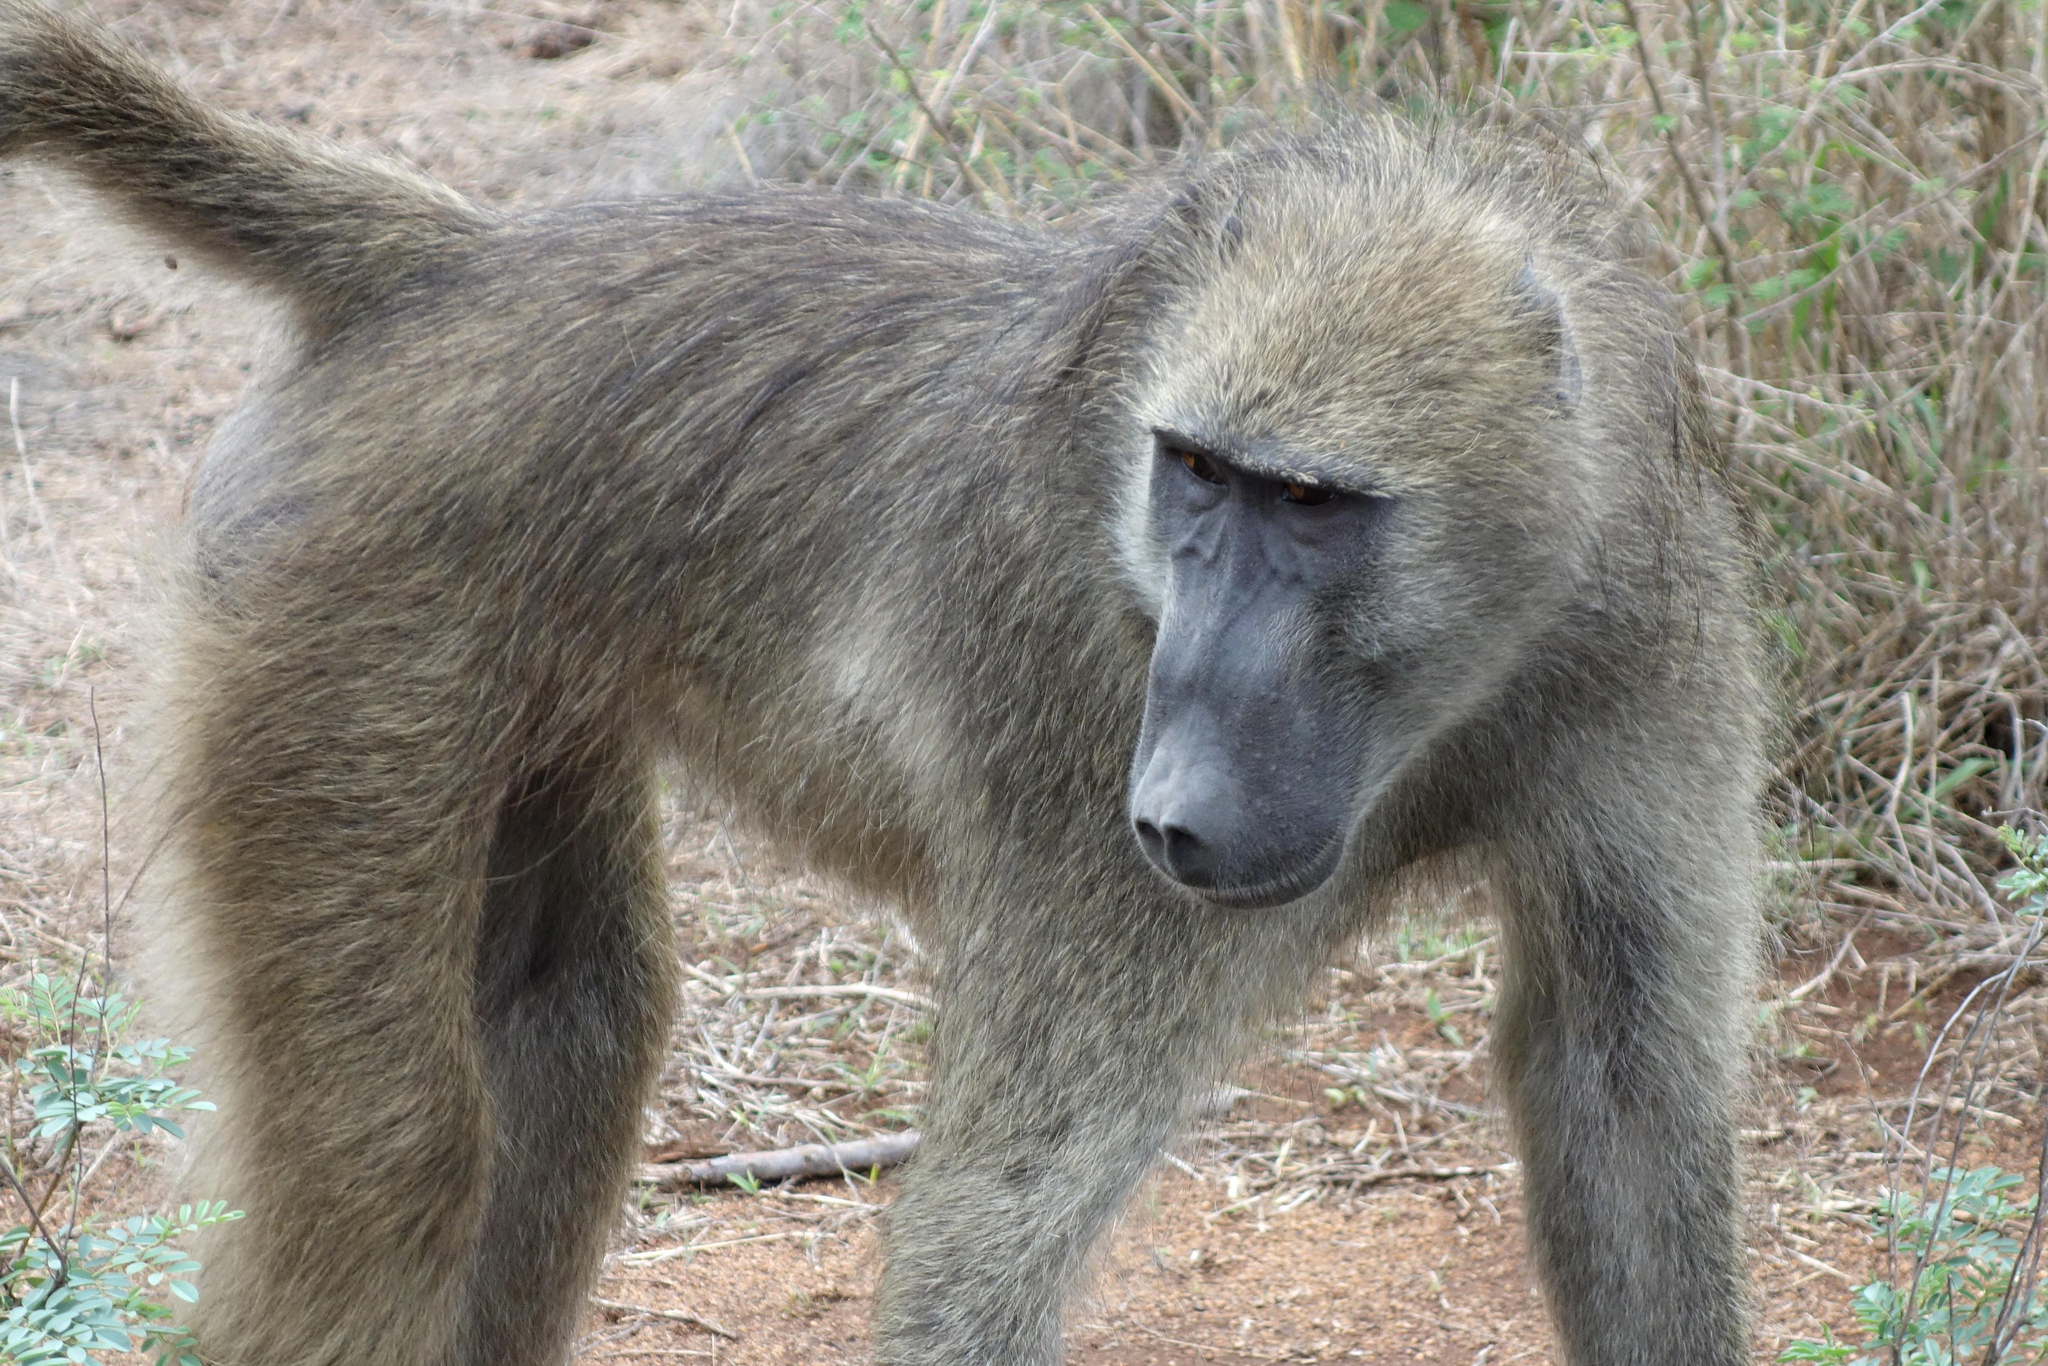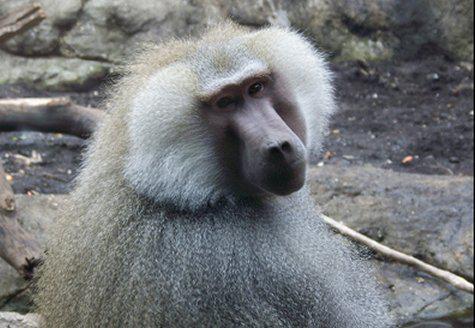The first image is the image on the left, the second image is the image on the right. For the images shown, is this caption "In one of the images there is a baby monkey cuddled in the arms of an adult monkey." true? Answer yes or no. No. The first image is the image on the left, the second image is the image on the right. For the images displayed, is the sentence "A baboon is hugging an animal to its chest in one image." factually correct? Answer yes or no. No. 